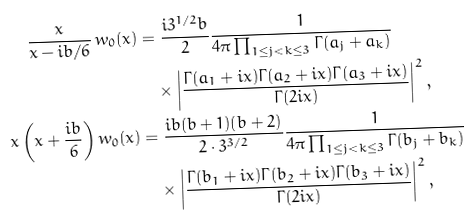<formula> <loc_0><loc_0><loc_500><loc_500>\frac { x } { x - i b / 6 } \, w _ { 0 } ( x ) & = \frac { i 3 ^ { 1 / 2 } b } { 2 } \frac { 1 } { 4 \pi \prod _ { 1 \leq j < k \leq 3 } \Gamma ( a _ { j } + a _ { k } ) } \\ & \quad \times \left | \frac { \Gamma ( a _ { 1 } + i x ) \Gamma ( a _ { 2 } + i x ) \Gamma ( a _ { 3 } + i x ) } { \Gamma ( 2 i x ) } \right | ^ { 2 } , \\ x \left ( x + \frac { i b } 6 \right ) w _ { 0 } ( x ) & = \frac { i b ( b + 1 ) ( b + 2 ) } { 2 \cdot 3 ^ { 3 / 2 } } \frac { 1 } { 4 \pi \prod _ { 1 \leq j < k \leq 3 } \Gamma ( b _ { j } + b _ { k } ) } \\ & \quad \times \left | \frac { \Gamma ( b _ { 1 } + i x ) \Gamma ( b _ { 2 } + i x ) \Gamma ( b _ { 3 } + i x ) } { \Gamma ( 2 i x ) } \right | ^ { 2 } ,</formula> 